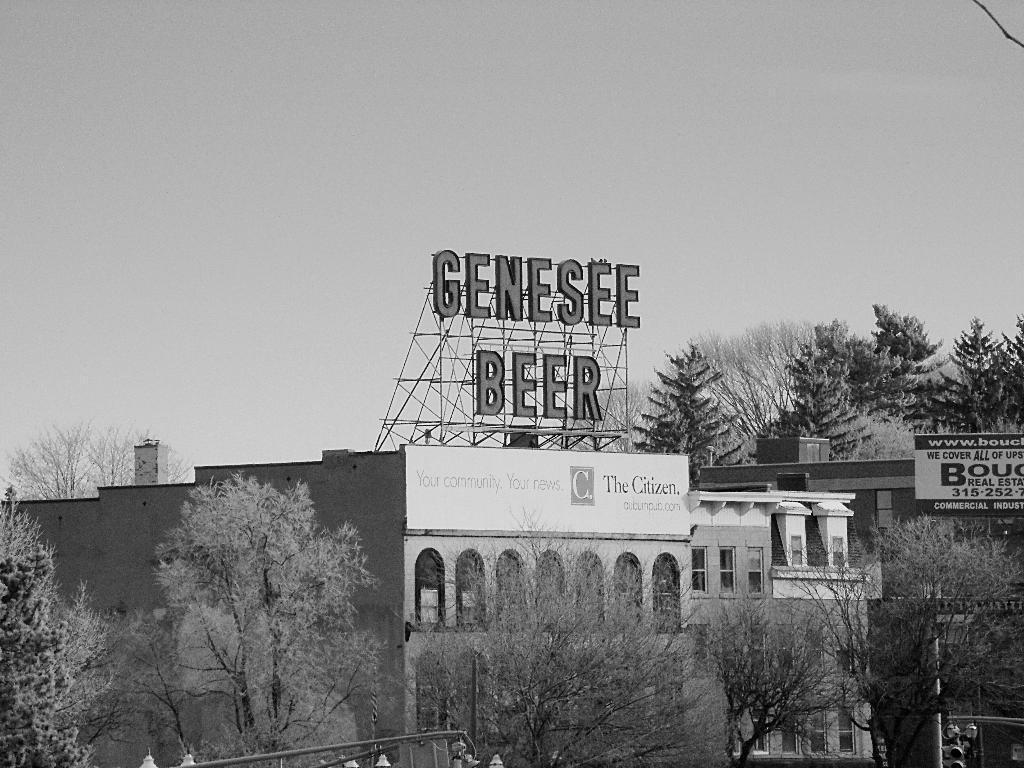Could you give a brief overview of what you see in this image? Bottom of the image few traffic lights are attached to the poles. There are few trees. Behind there are few buildings. Right side there are few trees. A board is attached to the building. Top of the image there is sky. 